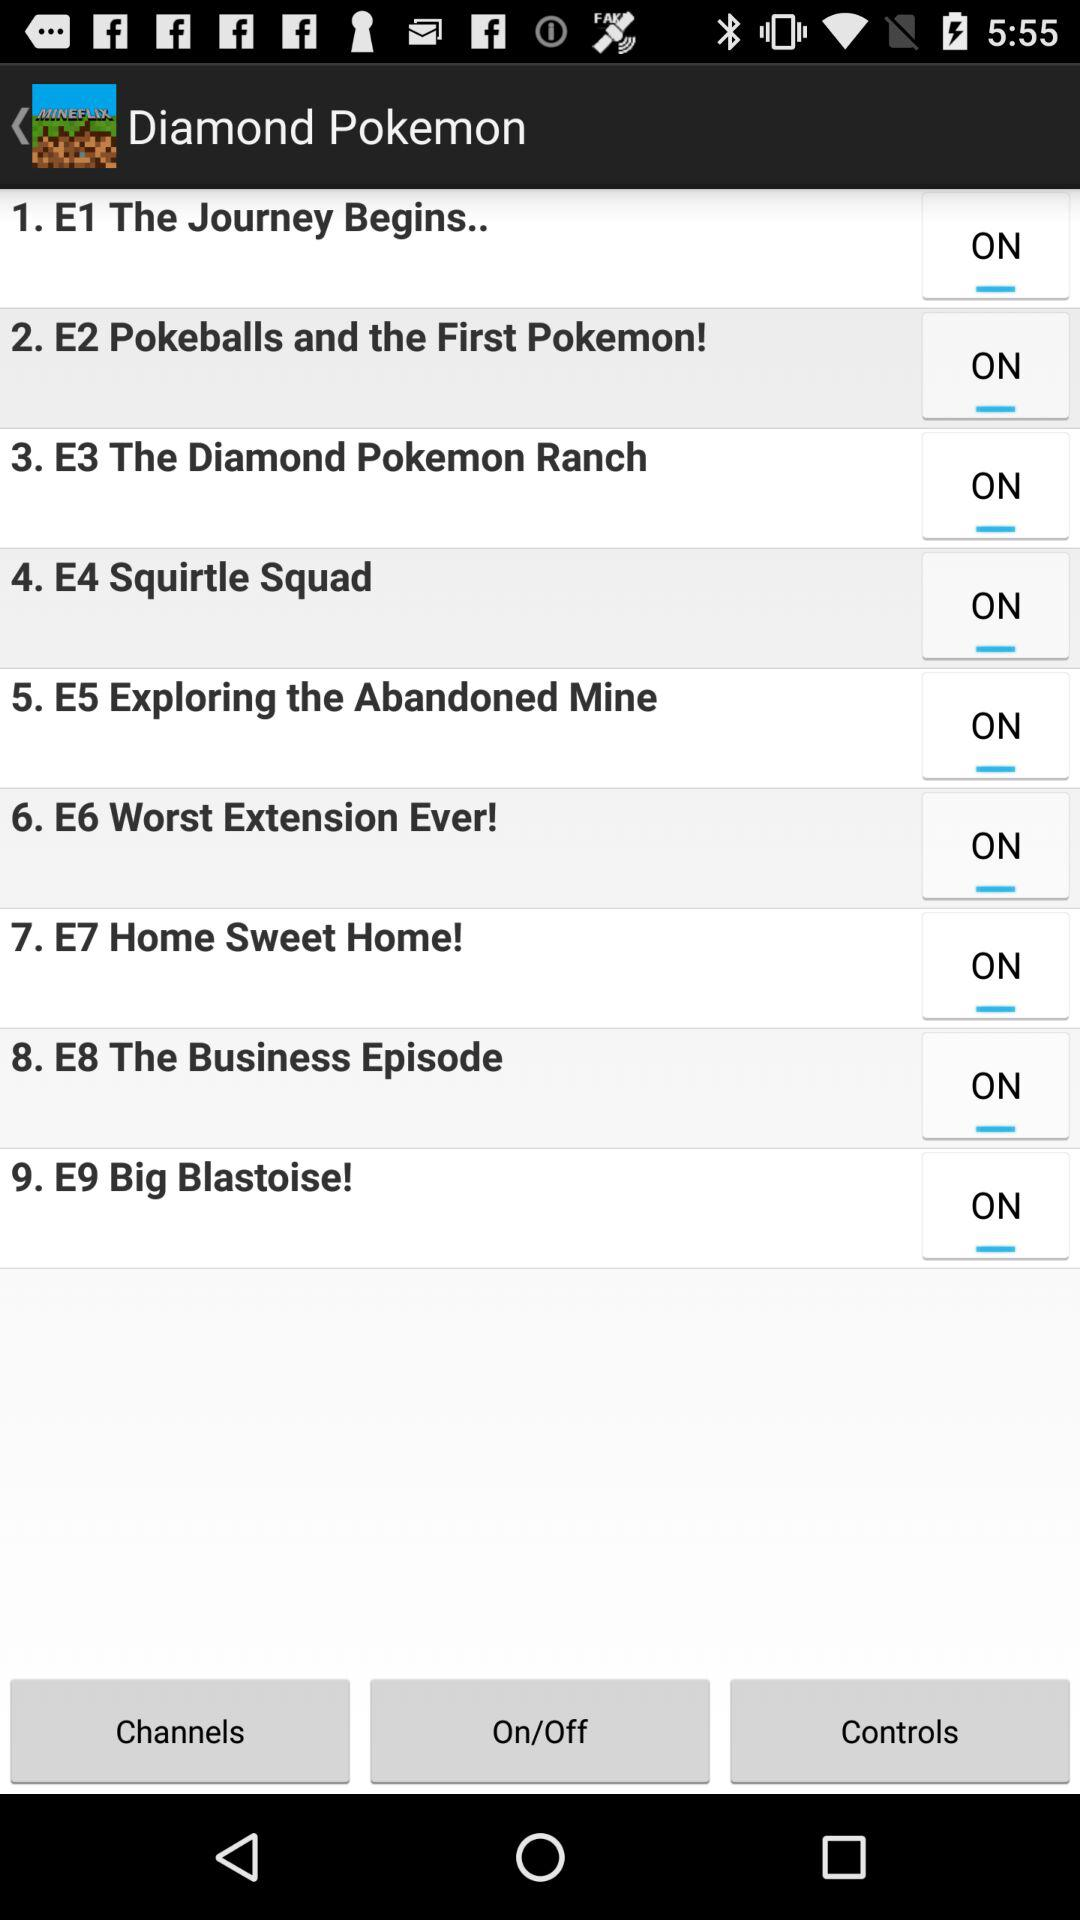Which is the episode number of "Big Blastoise!"? The episode number is 9. 